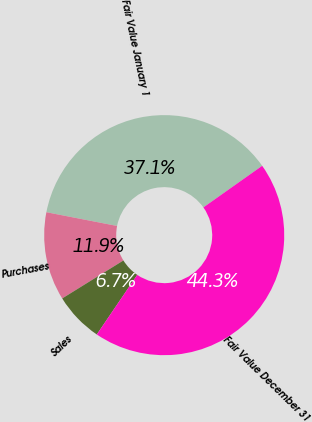<chart> <loc_0><loc_0><loc_500><loc_500><pie_chart><fcel>Fair Value January 1<fcel>Purchases<fcel>Sales<fcel>Fair Value December 31<nl><fcel>37.14%<fcel>11.9%<fcel>6.67%<fcel>44.29%<nl></chart> 